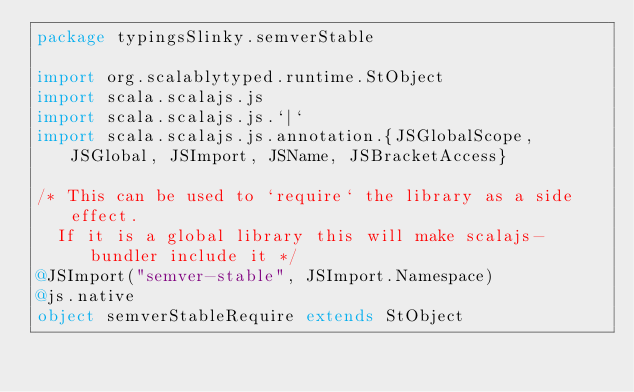<code> <loc_0><loc_0><loc_500><loc_500><_Scala_>package typingsSlinky.semverStable

import org.scalablytyped.runtime.StObject
import scala.scalajs.js
import scala.scalajs.js.`|`
import scala.scalajs.js.annotation.{JSGlobalScope, JSGlobal, JSImport, JSName, JSBracketAccess}

/* This can be used to `require` the library as a side effect.
  If it is a global library this will make scalajs-bundler include it */
@JSImport("semver-stable", JSImport.Namespace)
@js.native
object semverStableRequire extends StObject
</code> 